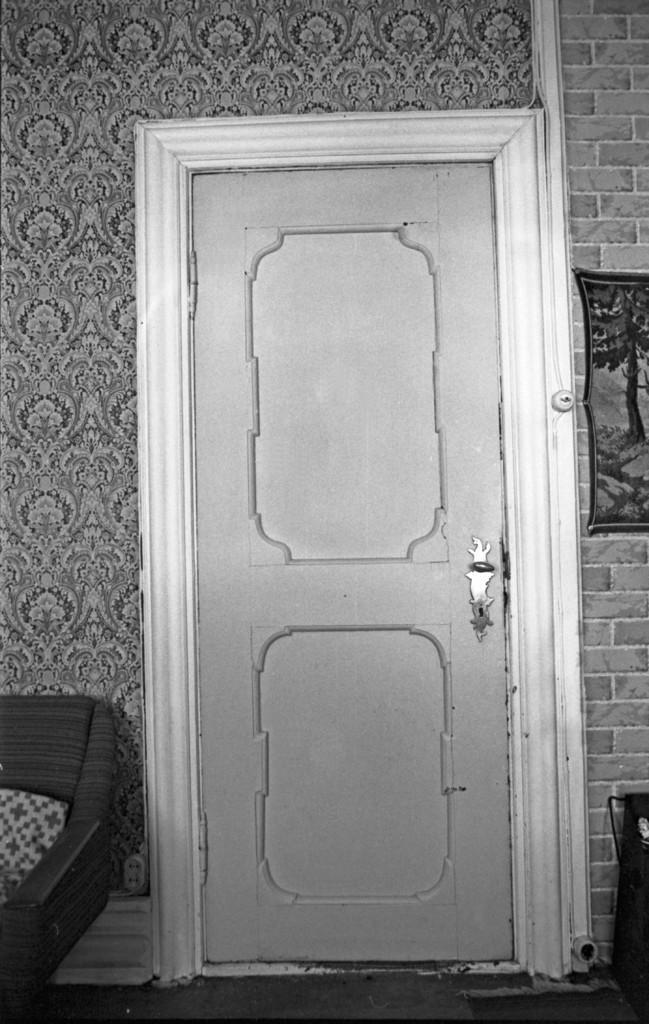Can you describe this image briefly? In this image we can see a door. Also there is a brick wall. On the wall there is a photo frame. And this is a black and white image. 